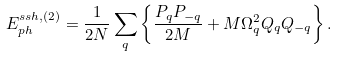<formula> <loc_0><loc_0><loc_500><loc_500>E _ { p h } ^ { s s h , ( 2 ) } = \frac { 1 } { 2 N } \sum _ { q } \left \{ \frac { P _ { q } P _ { - q } } { 2 M } + M \Omega _ { q } ^ { 2 } Q _ { q } Q _ { - q } \right \} .</formula> 